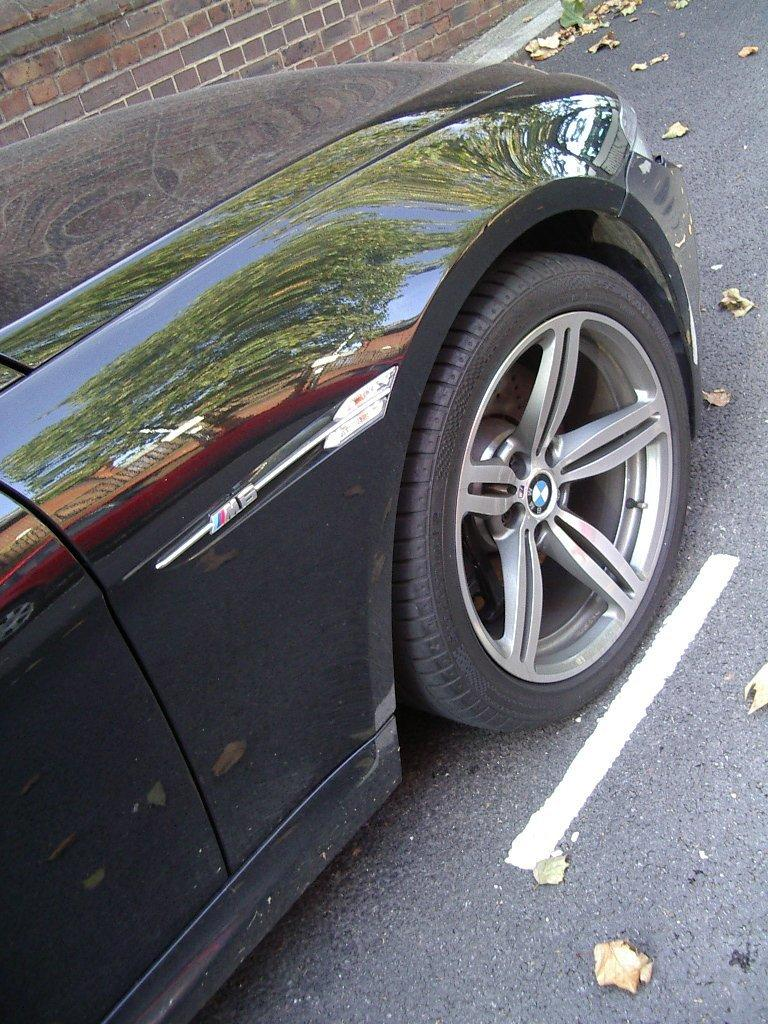What is the main subject of the image? The main subject of the image is a car. Can you describe the car in the image? The car is black. What is visible at the bottom of the image? There is a road at the bottom of the image. What can be seen in the background of the image? There is a wall in the background of the image. How many friends are sitting on the roof of the car in the image? There are no friends or roof present in the image; it features a black car on a road with a wall in the background. 